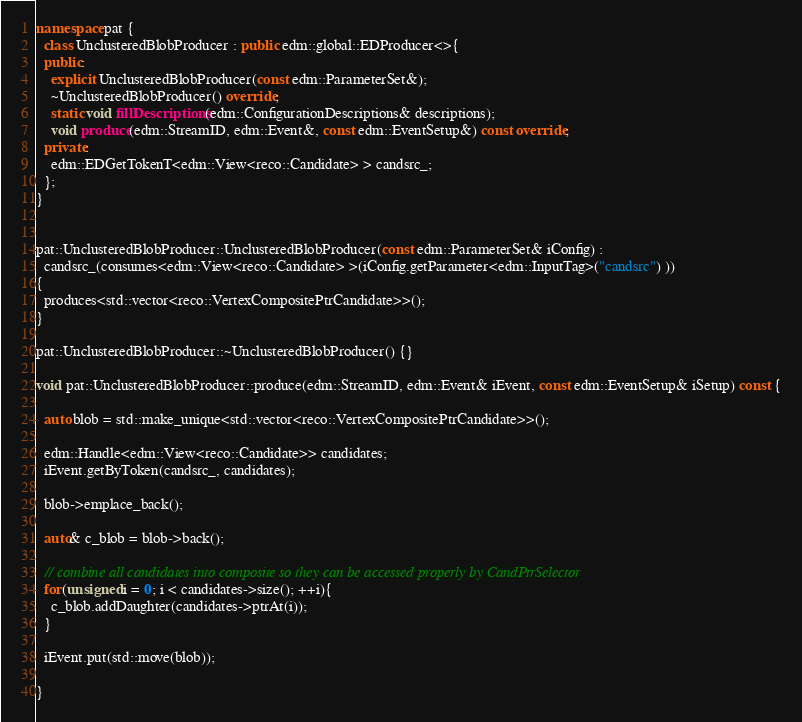Convert code to text. <code><loc_0><loc_0><loc_500><loc_500><_C++_>namespace pat {
  class UnclusteredBlobProducer : public edm::global::EDProducer<>{
  public:
    explicit UnclusteredBlobProducer(const edm::ParameterSet&);
    ~UnclusteredBlobProducer() override;
    static void fillDescriptions(edm::ConfigurationDescriptions& descriptions);
    void produce(edm::StreamID, edm::Event&, const edm::EventSetup&) const override;
  private:
    edm::EDGetTokenT<edm::View<reco::Candidate> > candsrc_;
  };
}


pat::UnclusteredBlobProducer::UnclusteredBlobProducer(const edm::ParameterSet& iConfig) :
  candsrc_(consumes<edm::View<reco::Candidate> >(iConfig.getParameter<edm::InputTag>("candsrc") ))
{
  produces<std::vector<reco::VertexCompositePtrCandidate>>();
}

pat::UnclusteredBlobProducer::~UnclusteredBlobProducer() {}

void pat::UnclusteredBlobProducer::produce(edm::StreamID, edm::Event& iEvent, const edm::EventSetup& iSetup) const {
  
  auto blob = std::make_unique<std::vector<reco::VertexCompositePtrCandidate>>();
  
  edm::Handle<edm::View<reco::Candidate>> candidates;
  iEvent.getByToken(candsrc_, candidates);
  
  blob->emplace_back();

  auto& c_blob = blob->back();

  // combine all candidates into composite so they can be accessed properly by CandPtrSelector
  for(unsigned i = 0; i < candidates->size(); ++i){
    c_blob.addDaughter(candidates->ptrAt(i));
  }

  iEvent.put(std::move(blob));
  
}
</code> 